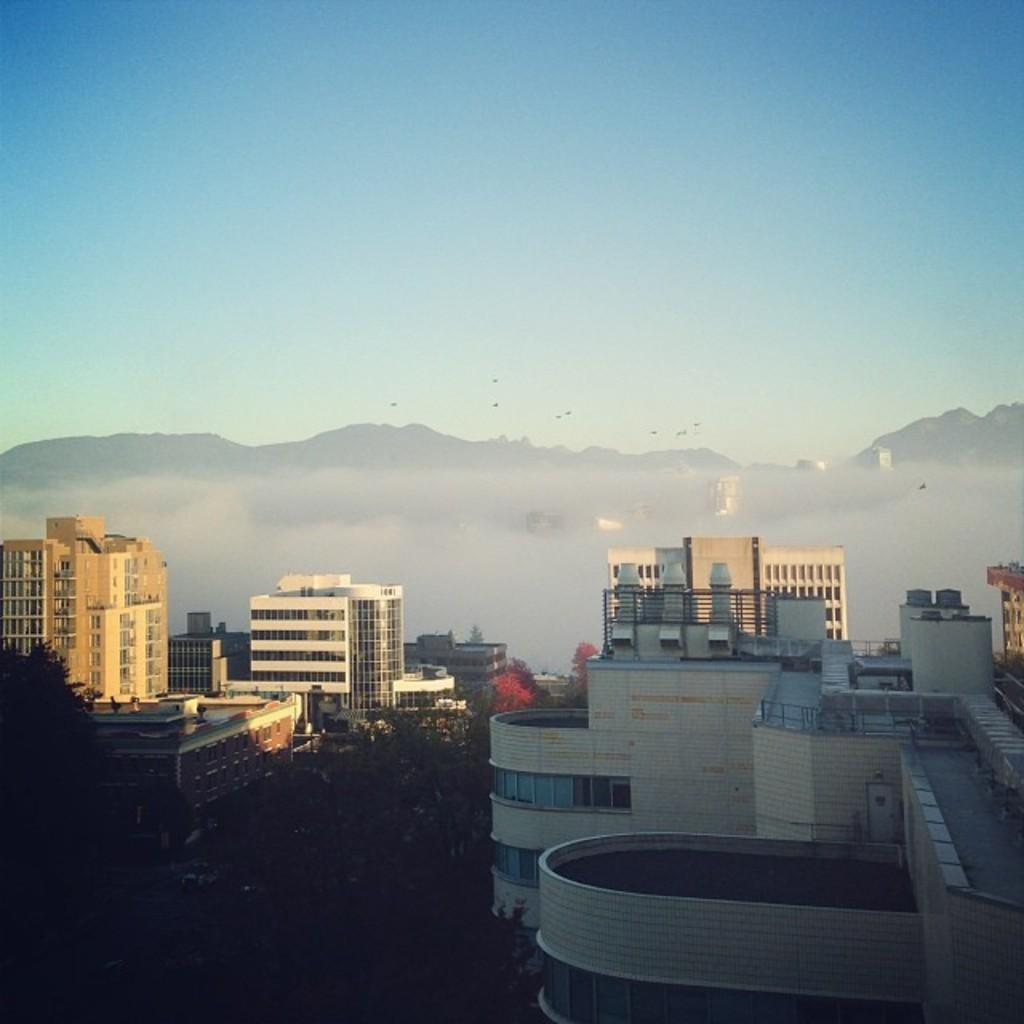What type of structures are present in the image? There are buildings with windows in the image. What natural elements can be seen in the image? There are trees and mountains in the image. What is visible in the background of the image? The sky is visible in the background of the image. How does the digestion process affect the nut content in the image? There is no reference to digestion or nut content in the image, as it features buildings, trees, mountains, and the sky. 